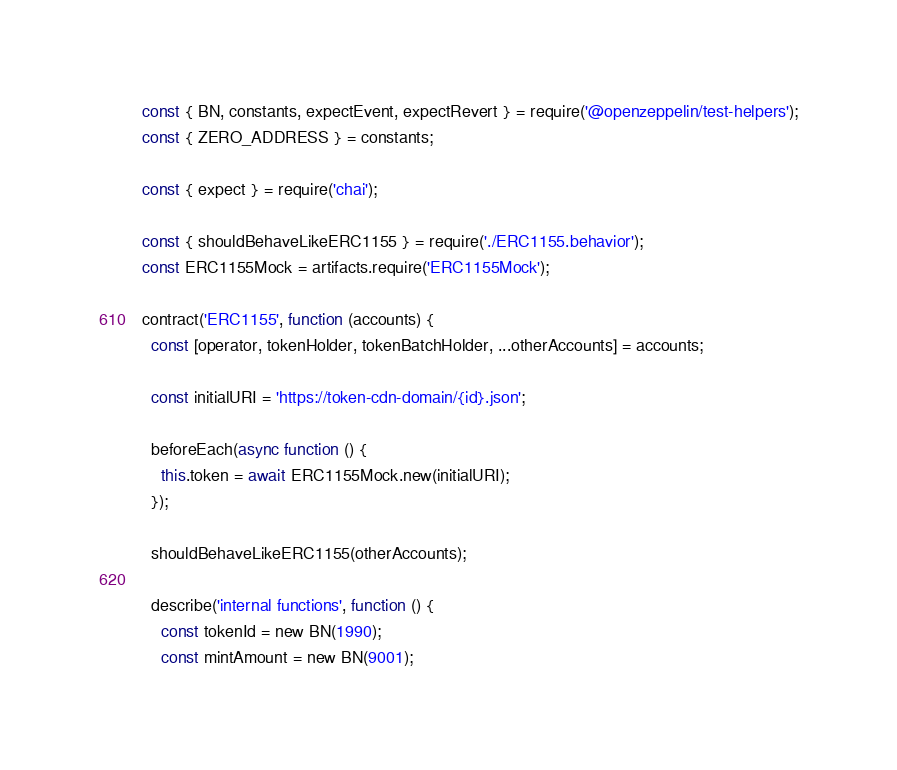Convert code to text. <code><loc_0><loc_0><loc_500><loc_500><_JavaScript_>const { BN, constants, expectEvent, expectRevert } = require('@openzeppelin/test-helpers');
const { ZERO_ADDRESS } = constants;

const { expect } = require('chai');

const { shouldBehaveLikeERC1155 } = require('./ERC1155.behavior');
const ERC1155Mock = artifacts.require('ERC1155Mock');

contract('ERC1155', function (accounts) {
  const [operator, tokenHolder, tokenBatchHolder, ...otherAccounts] = accounts;

  const initialURI = 'https://token-cdn-domain/{id}.json';

  beforeEach(async function () {
    this.token = await ERC1155Mock.new(initialURI);
  });

  shouldBehaveLikeERC1155(otherAccounts);

  describe('internal functions', function () {
    const tokenId = new BN(1990);
    const mintAmount = new BN(9001);</code> 